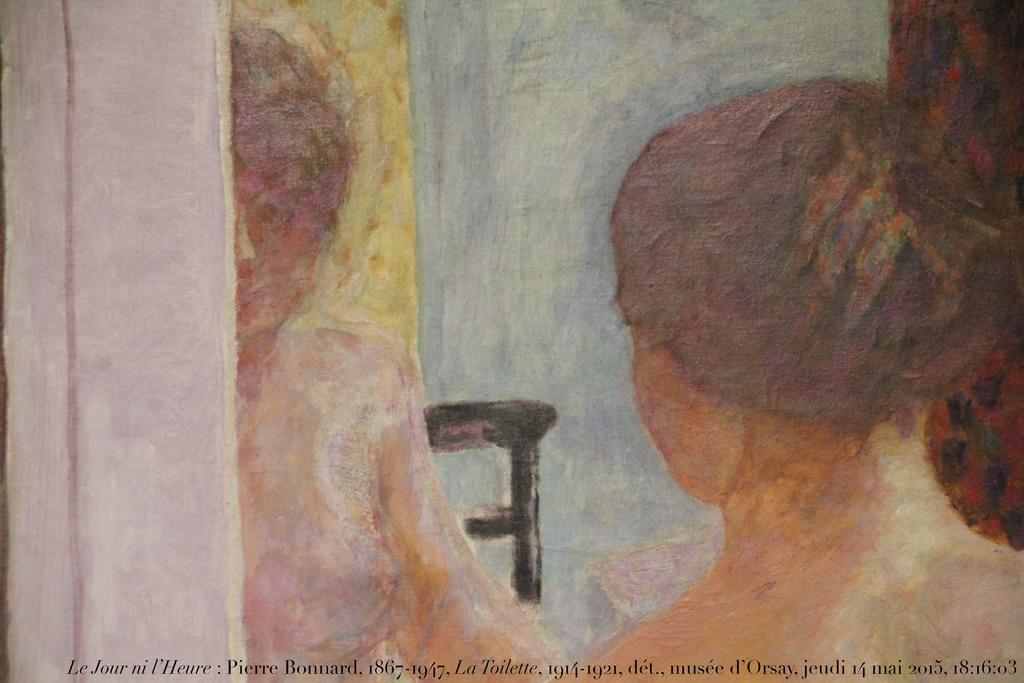What is the main subject of the image? The main subject of the image is a person. Can you describe any additional features or elements in the image? There is a watermark on the image. How many cherries can be seen in the image? There are no cherries present in the image. Can you describe the person's friend in the image? There is no mention of a friend or any other person in the image. 